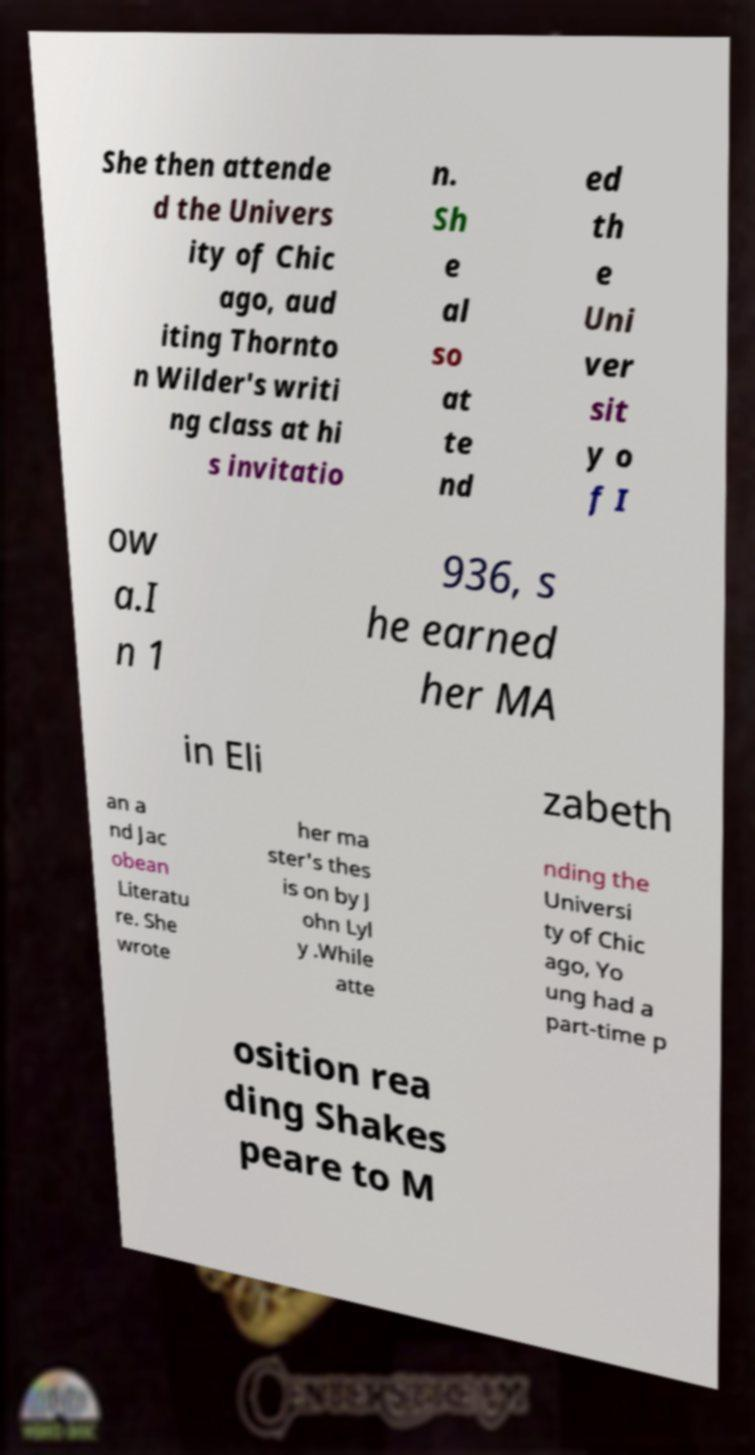There's text embedded in this image that I need extracted. Can you transcribe it verbatim? She then attende d the Univers ity of Chic ago, aud iting Thornto n Wilder's writi ng class at hi s invitatio n. Sh e al so at te nd ed th e Uni ver sit y o f I ow a.I n 1 936, s he earned her MA in Eli zabeth an a nd Jac obean Literatu re. She wrote her ma ster's thes is on by J ohn Lyl y .While atte nding the Universi ty of Chic ago, Yo ung had a part-time p osition rea ding Shakes peare to M 